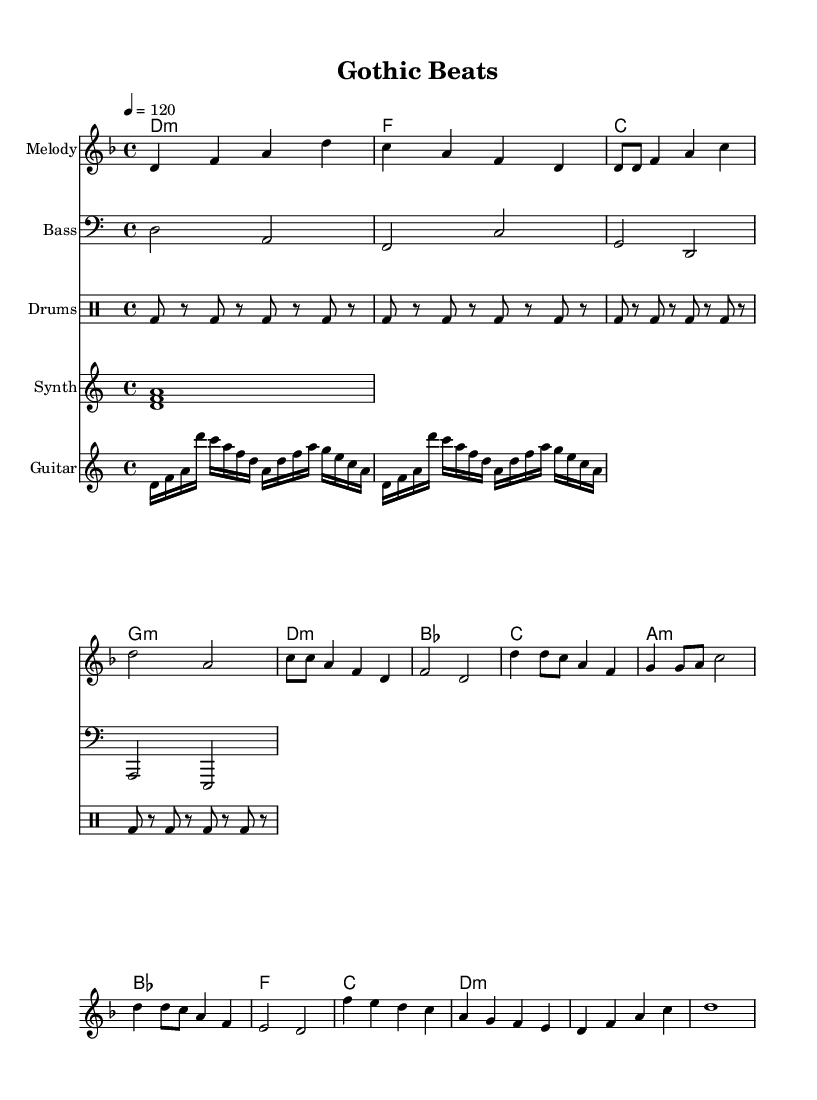what is the key signature of this music? The key signature indicated at the beginning of the piece is D minor, which is characterized by one flat.
Answer: D minor what is the time signature of this music? The time signature shown at the start is 4/4, meaning there are four beats per measure and each quarter note receives one beat.
Answer: 4/4 what is the tempo marking for this piece? The tempo marking indicates a pace of 120 beats per minute, suggesting a moderately fast tempo for performance.
Answer: 120 how many measures are there in the chorus section? By analyzing the written music, the chorus section contains four complete measures, reflecting the common structure in pop music for thematic sections.
Answer: 4 which instrument features a repeating pattern of bass drum in the percussion section? The information shows that the drum pattern is written for a drum staff, where a bass drum plays a repeated rhythm emphasizing the downbeats.
Answer: Bass drum what is the deviation in dynamics between the verse and chorus sections? The chorus is often more dynamic and energetic, typically requiring a louder intensity, while the verse tends to have softer dynamics, reflecting a common pop arrangement.
Answer: Louder (Chorus) / Softer (Verse) how many chords are used in the bridge section? Upon examining the bridge section, it becomes apparent that there are three distinct chords played, demonstrating a typical chord progression in pop music composition.
Answer: 3 